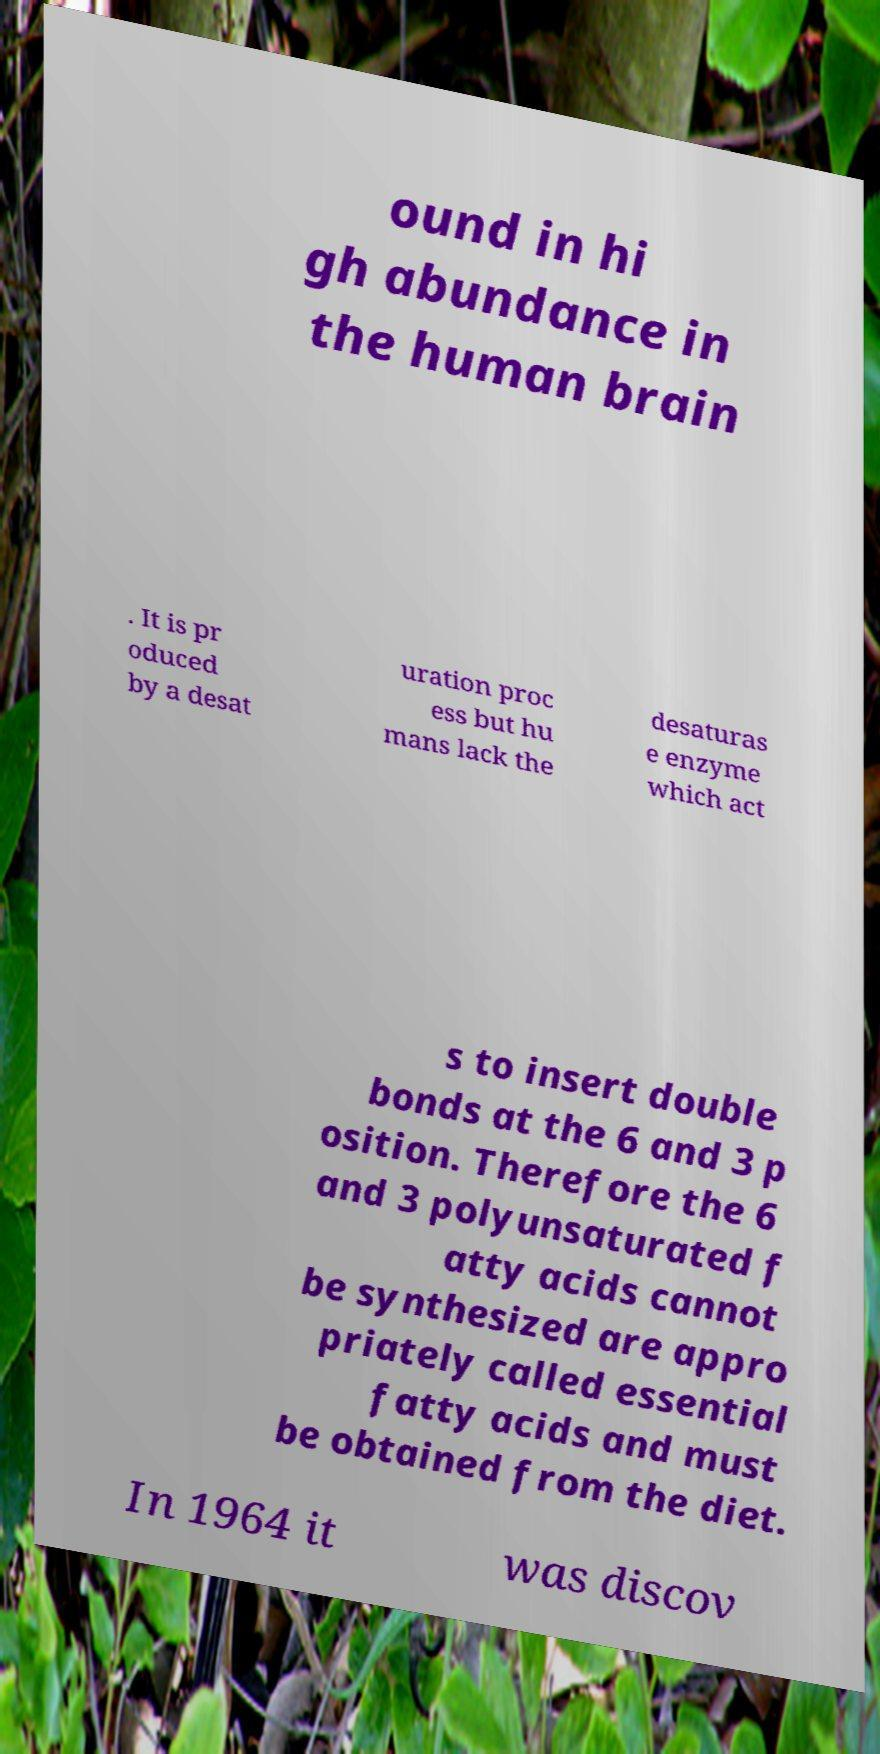I need the written content from this picture converted into text. Can you do that? ound in hi gh abundance in the human brain . It is pr oduced by a desat uration proc ess but hu mans lack the desaturas e enzyme which act s to insert double bonds at the 6 and 3 p osition. Therefore the 6 and 3 polyunsaturated f atty acids cannot be synthesized are appro priately called essential fatty acids and must be obtained from the diet. In 1964 it was discov 